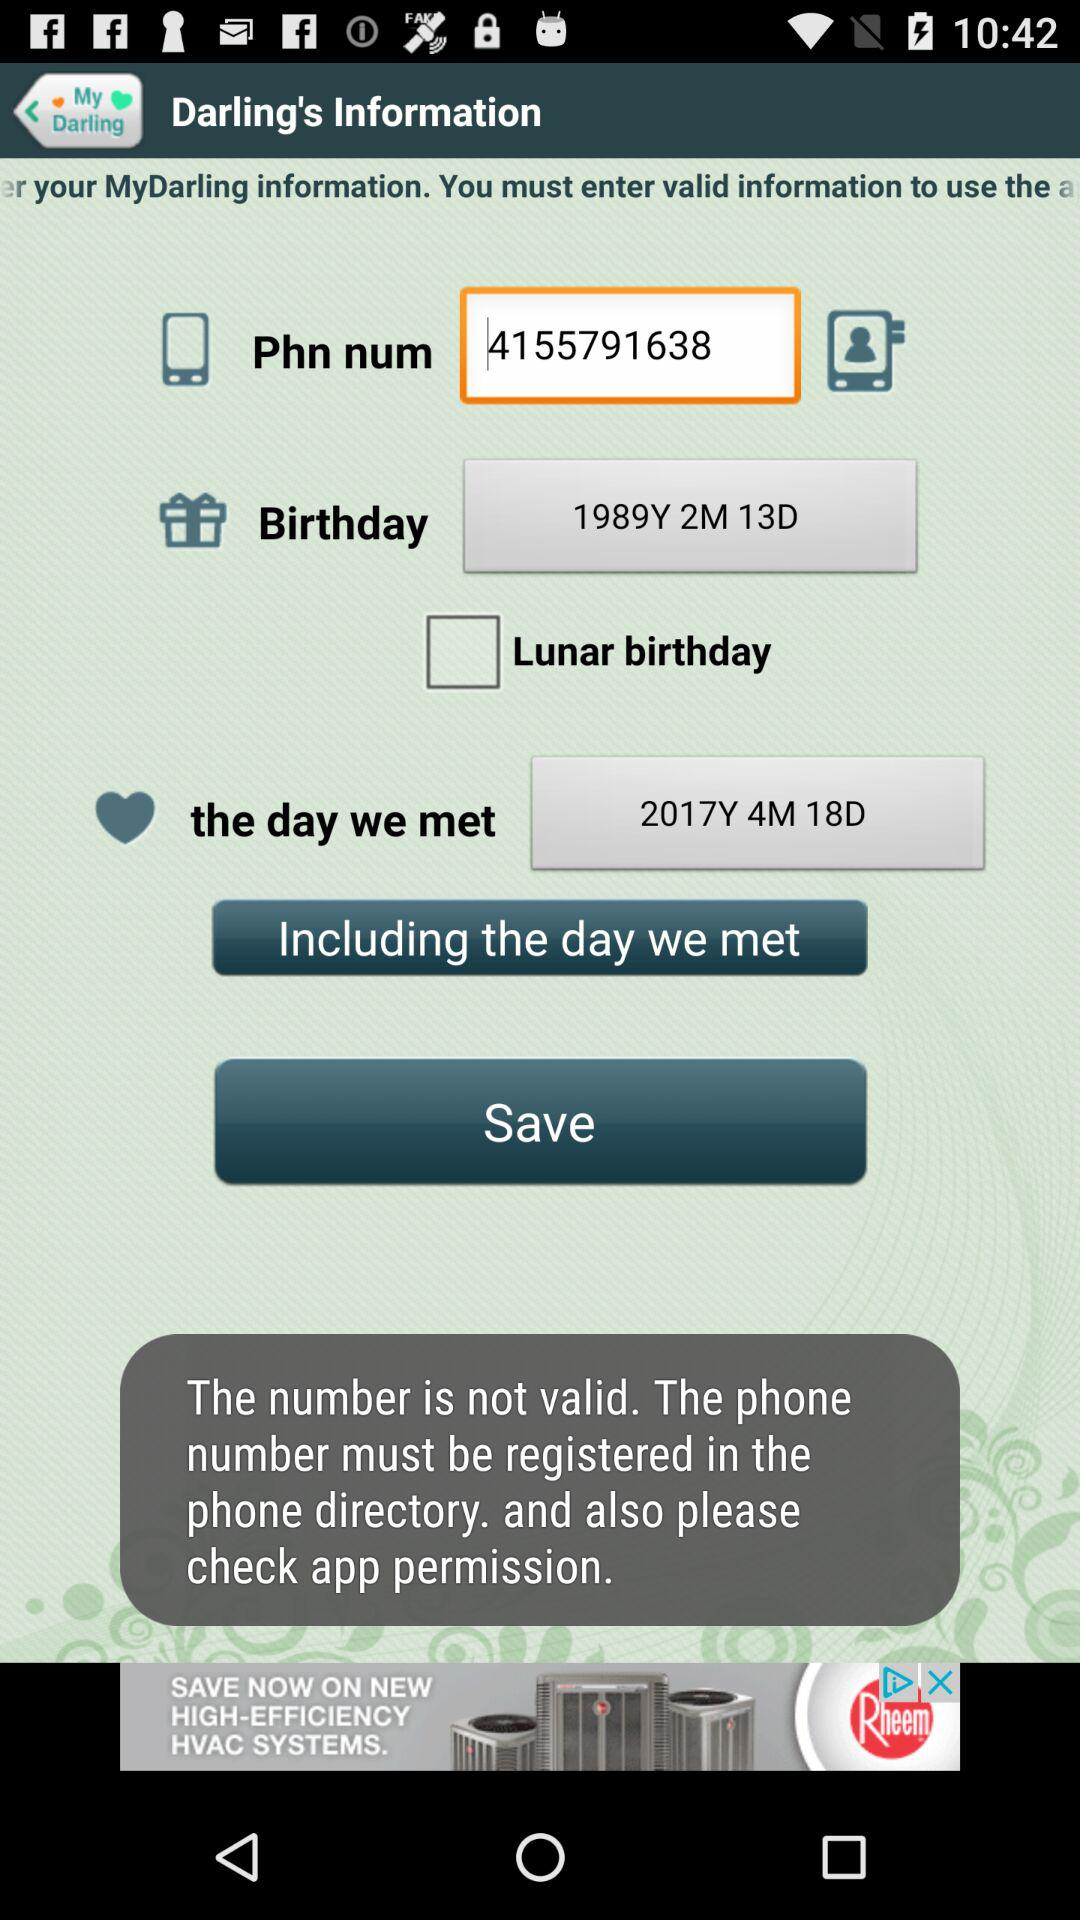On what date did they meet? They met on April 18, 2017. 